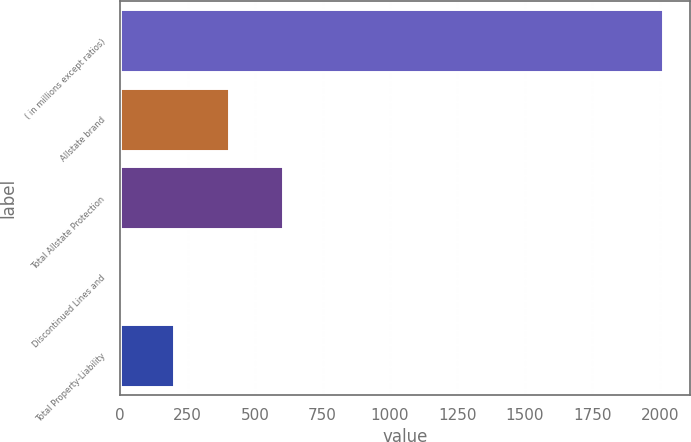<chart> <loc_0><loc_0><loc_500><loc_500><bar_chart><fcel>( in millions except ratios)<fcel>Allstate brand<fcel>Total Allstate Protection<fcel>Discontinued Lines and<fcel>Total Property-Liability<nl><fcel>2010<fcel>402.08<fcel>603.07<fcel>0.1<fcel>201.09<nl></chart> 